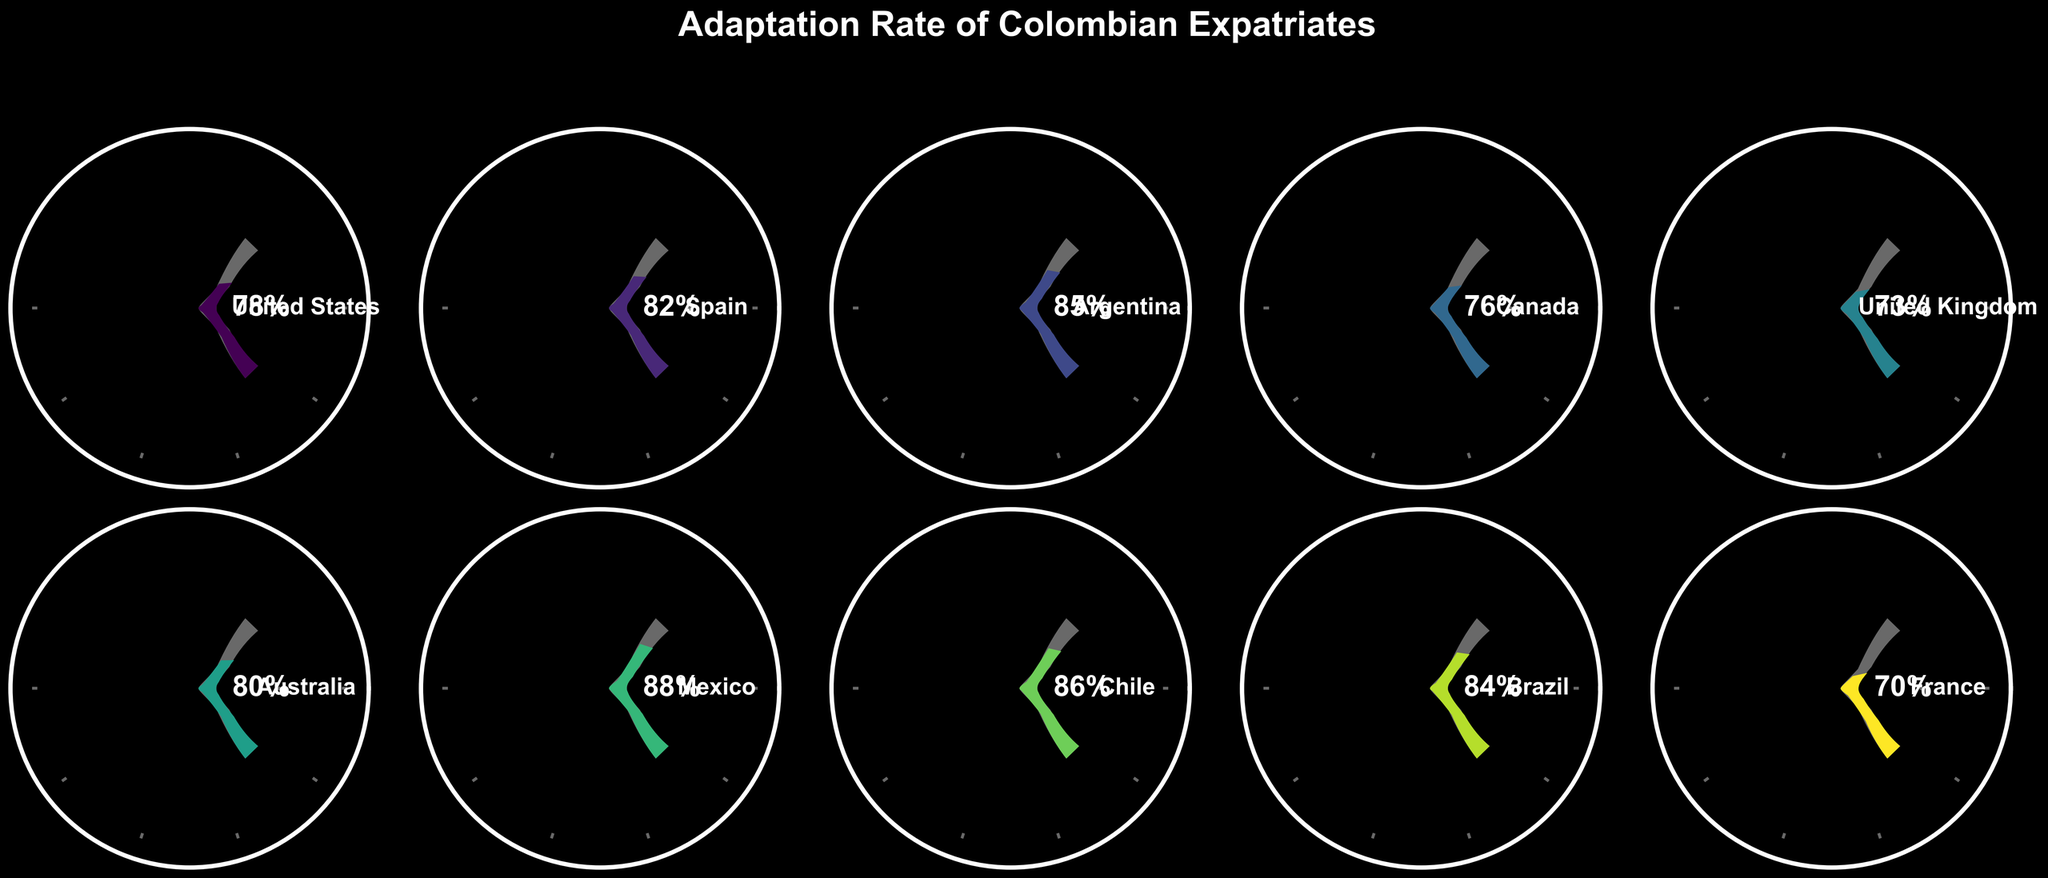what's the adaptation rate for expatriates in France? The adaptation rate for France is directly shown in the gauge chart labeled 'France' as 70%.
Answer: 70% Which country has the highest adaptation rate? By comparing the ratings in all the gauge charts, Mexico has the highest adaptation rate at 88%.
Answer: Mexico What's the average adaptation rate across all listed countries? Add up all the adaptation rates (78 + 82 + 85 + 76 + 73 + 80 + 88 + 86 + 84 + 70) to get 732, and then divide by the number of countries, which is 10. The average is 732 / 10 = 73.2%.
Answer: 73.2% Which countries have an adaptation rate above 80%? Identify the countries from the gauge charts with an adaptation rate greater than 80%. These are Spain (82%), Argentina (85%), Australia (80%), Mexico (88%), Chile (86%), and Brazil (84%).
Answer: Spain, Argentina, Australia, Mexico, Chile, Brazil How many countries have an adaptation rate less than 75%? From the gauge charts, count the countries with an adaptation rate below 75%. These are the United Kingdom (73%), and France (70%), resulting in 2 countries.
Answer: 2 Which country shows a lower adaptation rate, the United States or Canada? From the gauge charts, compare the adaptation rates for the United States (78%) and Canada (76%). Canada has the lower rate of 76%.
Answer: Canada What's the difference in adaptation rates between the country with the highest rate and the country with the lowest rate? Subtract the adaptation rate of France (70%) from the rate of Mexico (88%), which gives 18%.
Answer: 18% Which country has an adaptation rate closest to 85%? Compare the adaptation rates to 85%. Argentina has an adaptation rate of 85%, which is exactly 85%.
Answer: Argentina What's the combined adaptation rate of Brazil and Chile? Add the adaptation rates for Brazil (84%) and Chile (86%). The total is 84 + 86 = 170%.
Answer: 170% Are there more countries with adaptation rates above or below 80%? Count the number of countries with adaptation rates above 80% (Spain, Argentina, Mexico, Chile, Brazil) which totals 5, and those below 80% (United States, Canada, United Kingdom, France) which totals 4, the number is equal for Australia. There are slightly more countries with adaptation rates above 80%.
Answer: Above 